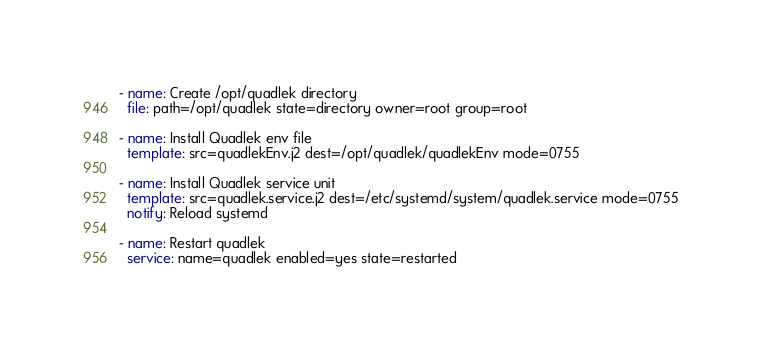<code> <loc_0><loc_0><loc_500><loc_500><_YAML_>- name: Create /opt/quadlek directory
  file: path=/opt/quadlek state=directory owner=root group=root

- name: Install Quadlek env file
  template: src=quadlekEnv.j2 dest=/opt/quadlek/quadlekEnv mode=0755

- name: Install Quadlek service unit
  template: src=quadlek.service.j2 dest=/etc/systemd/system/quadlek.service mode=0755
  notify: Reload systemd

- name: Restart quadlek
  service: name=quadlek enabled=yes state=restarted</code> 